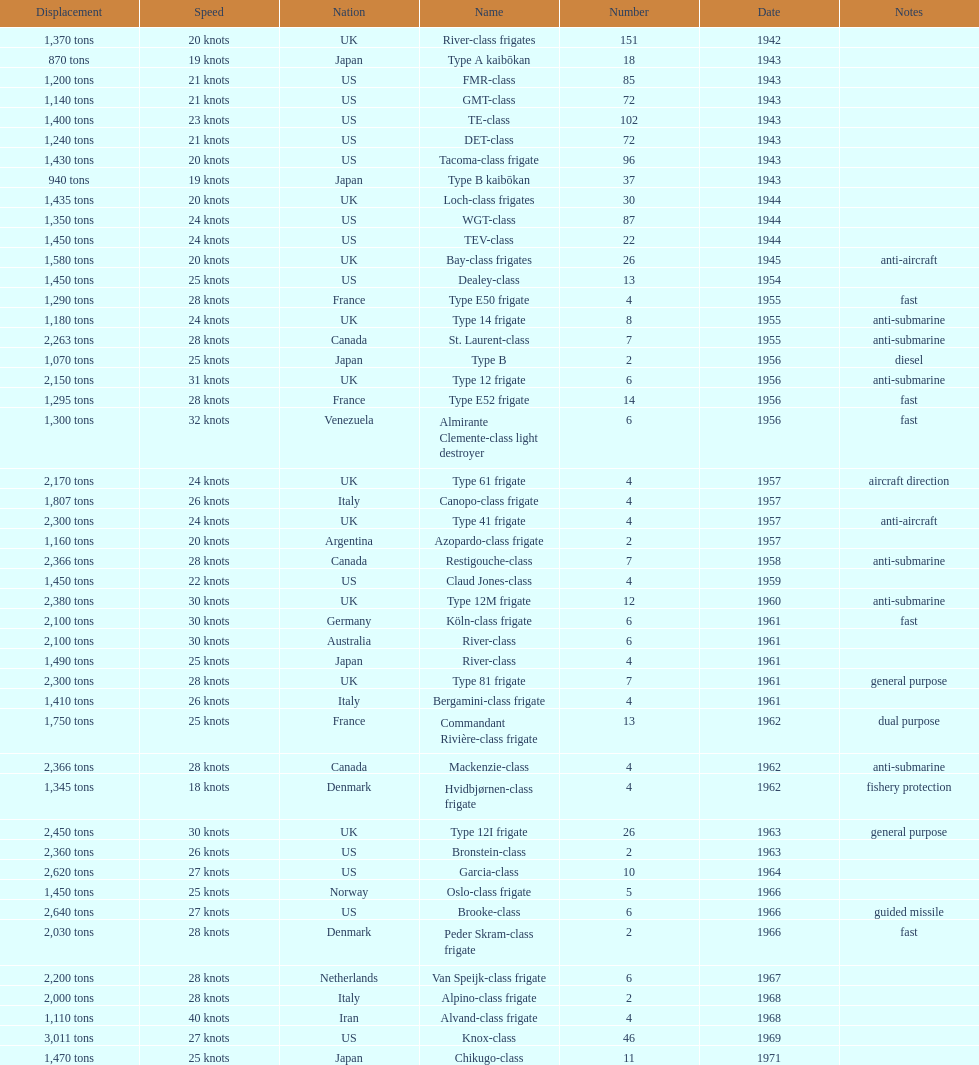How many tons does the te-class displace? 1,400 tons. 